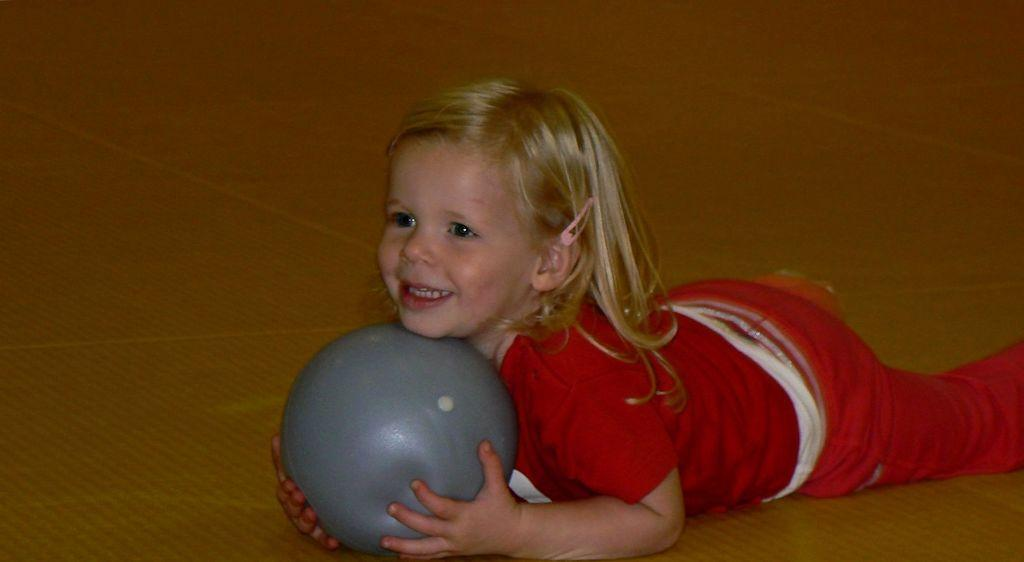Who is the main subject in the image? There is a girl in the image. What is the girl doing in the image? The girl is laying on a surface. What object is the girl holding in the image? The girl is holding a ball. What type of smoke can be seen coming from the ball in the image? There is no smoke present in the image, and the ball is not emitting any smoke. 